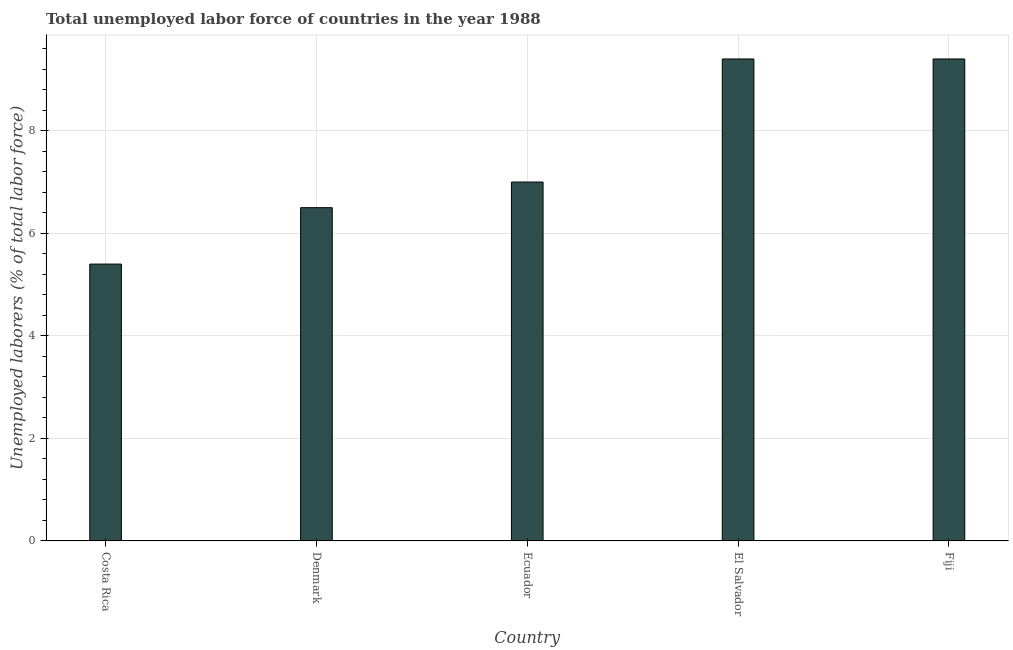Does the graph contain grids?
Your answer should be very brief. Yes. What is the title of the graph?
Your response must be concise. Total unemployed labor force of countries in the year 1988. What is the label or title of the X-axis?
Provide a short and direct response. Country. What is the label or title of the Y-axis?
Provide a short and direct response. Unemployed laborers (% of total labor force). What is the total unemployed labour force in Denmark?
Give a very brief answer. 6.5. Across all countries, what is the maximum total unemployed labour force?
Your answer should be very brief. 9.4. Across all countries, what is the minimum total unemployed labour force?
Your response must be concise. 5.4. In which country was the total unemployed labour force maximum?
Offer a terse response. El Salvador. What is the sum of the total unemployed labour force?
Your response must be concise. 37.7. What is the difference between the total unemployed labour force in Denmark and Ecuador?
Provide a succinct answer. -0.5. What is the average total unemployed labour force per country?
Ensure brevity in your answer.  7.54. What is the median total unemployed labour force?
Offer a very short reply. 7. In how many countries, is the total unemployed labour force greater than 3.6 %?
Your response must be concise. 5. What is the ratio of the total unemployed labour force in Ecuador to that in El Salvador?
Your answer should be very brief. 0.74. Is the total unemployed labour force in Costa Rica less than that in Ecuador?
Your answer should be compact. Yes. Is the difference between the total unemployed labour force in Costa Rica and Denmark greater than the difference between any two countries?
Your answer should be very brief. No. Is the sum of the total unemployed labour force in Denmark and El Salvador greater than the maximum total unemployed labour force across all countries?
Give a very brief answer. Yes. What is the difference between the highest and the lowest total unemployed labour force?
Offer a terse response. 4. How many bars are there?
Offer a very short reply. 5. Are all the bars in the graph horizontal?
Offer a very short reply. No. How many countries are there in the graph?
Your answer should be very brief. 5. What is the difference between two consecutive major ticks on the Y-axis?
Make the answer very short. 2. Are the values on the major ticks of Y-axis written in scientific E-notation?
Your answer should be compact. No. What is the Unemployed laborers (% of total labor force) of Costa Rica?
Provide a short and direct response. 5.4. What is the Unemployed laborers (% of total labor force) in Ecuador?
Give a very brief answer. 7. What is the Unemployed laborers (% of total labor force) of El Salvador?
Give a very brief answer. 9.4. What is the Unemployed laborers (% of total labor force) of Fiji?
Your answer should be compact. 9.4. What is the difference between the Unemployed laborers (% of total labor force) in Costa Rica and Ecuador?
Provide a short and direct response. -1.6. What is the difference between the Unemployed laborers (% of total labor force) in Costa Rica and Fiji?
Your answer should be very brief. -4. What is the difference between the Unemployed laborers (% of total labor force) in Denmark and Ecuador?
Your answer should be very brief. -0.5. What is the difference between the Unemployed laborers (% of total labor force) in Denmark and Fiji?
Make the answer very short. -2.9. What is the ratio of the Unemployed laborers (% of total labor force) in Costa Rica to that in Denmark?
Your response must be concise. 0.83. What is the ratio of the Unemployed laborers (% of total labor force) in Costa Rica to that in Ecuador?
Offer a very short reply. 0.77. What is the ratio of the Unemployed laborers (% of total labor force) in Costa Rica to that in El Salvador?
Provide a short and direct response. 0.57. What is the ratio of the Unemployed laborers (% of total labor force) in Costa Rica to that in Fiji?
Give a very brief answer. 0.57. What is the ratio of the Unemployed laborers (% of total labor force) in Denmark to that in Ecuador?
Your answer should be compact. 0.93. What is the ratio of the Unemployed laborers (% of total labor force) in Denmark to that in El Salvador?
Offer a very short reply. 0.69. What is the ratio of the Unemployed laborers (% of total labor force) in Denmark to that in Fiji?
Your response must be concise. 0.69. What is the ratio of the Unemployed laborers (% of total labor force) in Ecuador to that in El Salvador?
Your answer should be compact. 0.74. What is the ratio of the Unemployed laborers (% of total labor force) in Ecuador to that in Fiji?
Provide a succinct answer. 0.74. What is the ratio of the Unemployed laborers (% of total labor force) in El Salvador to that in Fiji?
Your response must be concise. 1. 